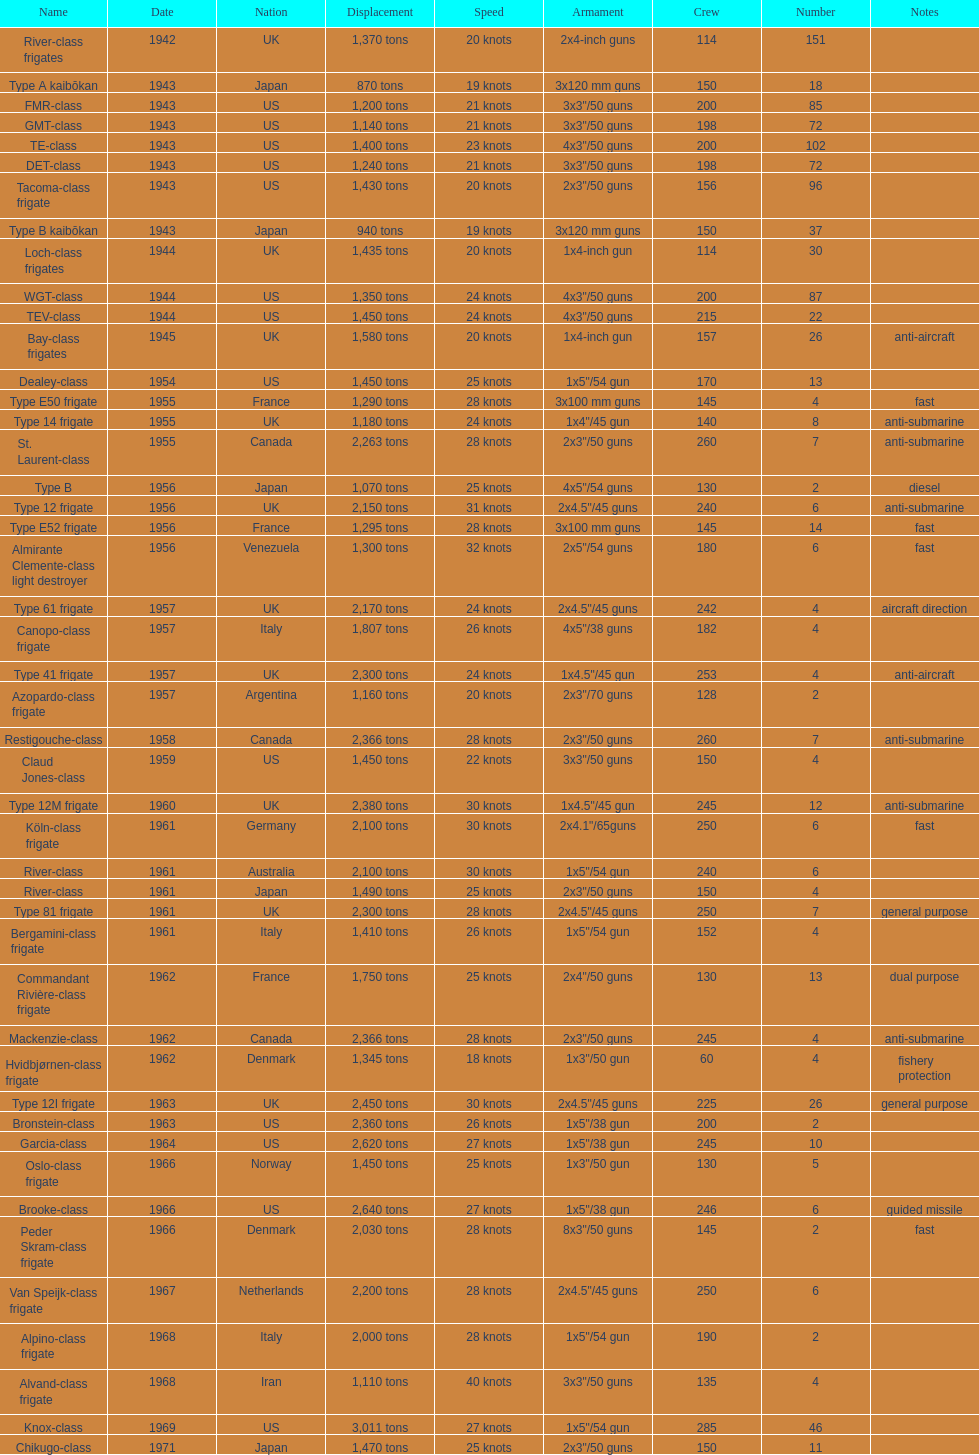How many tons does the te-class displace? 1,400 tons. 